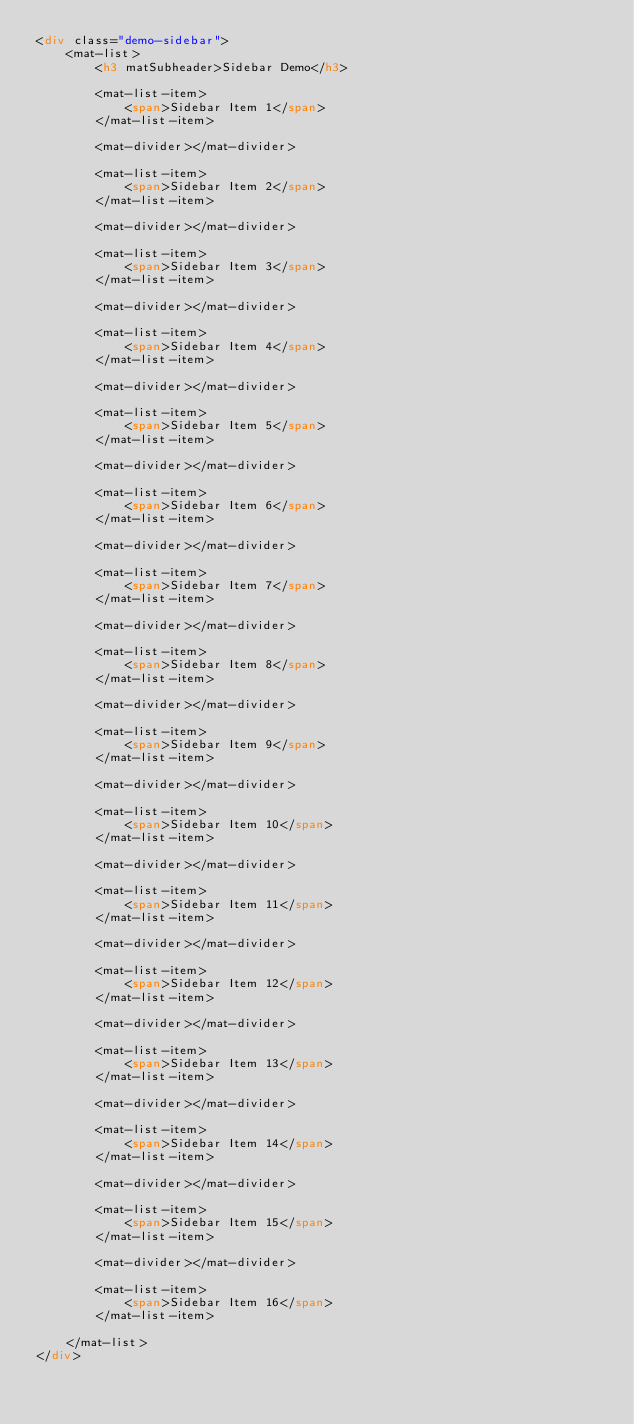<code> <loc_0><loc_0><loc_500><loc_500><_HTML_><div class="demo-sidebar">
    <mat-list>
        <h3 matSubheader>Sidebar Demo</h3>

        <mat-list-item>
            <span>Sidebar Item 1</span>
        </mat-list-item>

        <mat-divider></mat-divider>

        <mat-list-item>
            <span>Sidebar Item 2</span>
        </mat-list-item>

        <mat-divider></mat-divider>

        <mat-list-item>
            <span>Sidebar Item 3</span>
        </mat-list-item>

        <mat-divider></mat-divider>

        <mat-list-item>
            <span>Sidebar Item 4</span>
        </mat-list-item>

        <mat-divider></mat-divider>

        <mat-list-item>
            <span>Sidebar Item 5</span>
        </mat-list-item>

        <mat-divider></mat-divider>

        <mat-list-item>
            <span>Sidebar Item 6</span>
        </mat-list-item>

        <mat-divider></mat-divider>

        <mat-list-item>
            <span>Sidebar Item 7</span>
        </mat-list-item>

        <mat-divider></mat-divider>

        <mat-list-item>
            <span>Sidebar Item 8</span>
        </mat-list-item>

        <mat-divider></mat-divider>

        <mat-list-item>
            <span>Sidebar Item 9</span>
        </mat-list-item>

        <mat-divider></mat-divider>

        <mat-list-item>
            <span>Sidebar Item 10</span>
        </mat-list-item>

        <mat-divider></mat-divider>

        <mat-list-item>
            <span>Sidebar Item 11</span>
        </mat-list-item>

        <mat-divider></mat-divider>

        <mat-list-item>
            <span>Sidebar Item 12</span>
        </mat-list-item>

        <mat-divider></mat-divider>

        <mat-list-item>
            <span>Sidebar Item 13</span>
        </mat-list-item>

        <mat-divider></mat-divider>

        <mat-list-item>
            <span>Sidebar Item 14</span>
        </mat-list-item>

        <mat-divider></mat-divider>

        <mat-list-item>
            <span>Sidebar Item 15</span>
        </mat-list-item>

        <mat-divider></mat-divider>

        <mat-list-item>
            <span>Sidebar Item 16</span>
        </mat-list-item>

    </mat-list>
</div>
</code> 